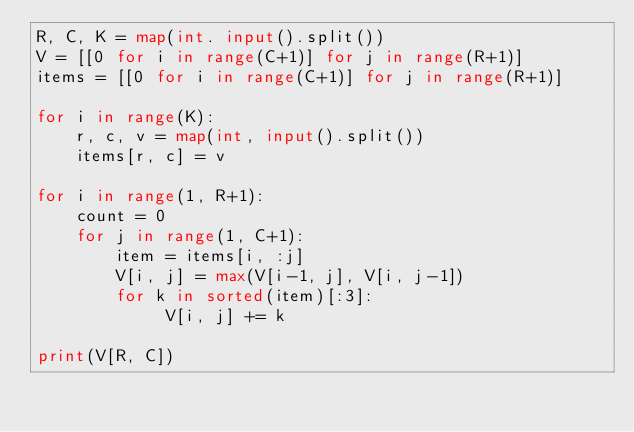<code> <loc_0><loc_0><loc_500><loc_500><_Python_>R, C, K = map(int. input().split())
V = [[0 for i in range(C+1)] for j in range(R+1)]
items = [[0 for i in range(C+1)] for j in range(R+1)]

for i in range(K):
    r, c, v = map(int, input().split())
    items[r, c] = v

for i in range(1, R+1):
    count = 0
    for j in range(1, C+1):
        item = items[i, :j]
        V[i, j] = max(V[i-1, j], V[i, j-1])
        for k in sorted(item)[:3]:
             V[i, j] += k

print(V[R, C])
</code> 